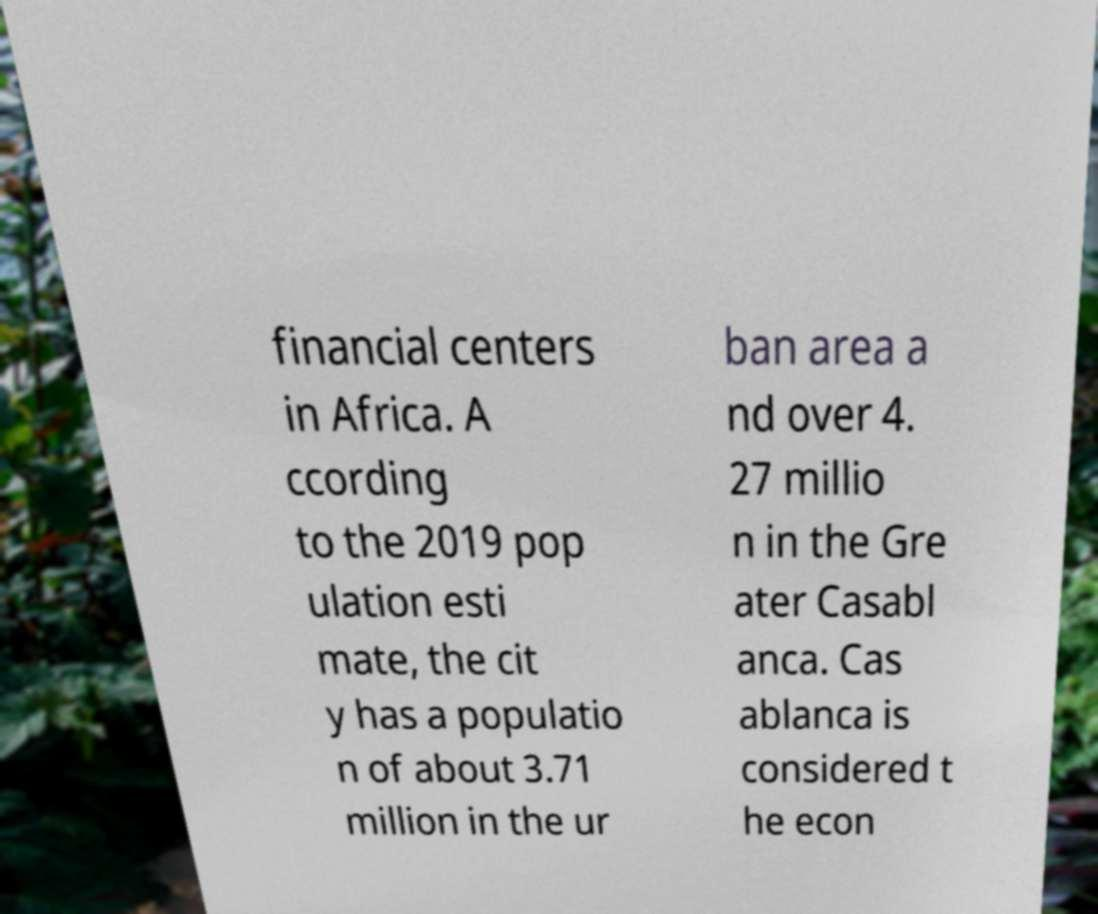Please identify and transcribe the text found in this image. financial centers in Africa. A ccording to the 2019 pop ulation esti mate, the cit y has a populatio n of about 3.71 million in the ur ban area a nd over 4. 27 millio n in the Gre ater Casabl anca. Cas ablanca is considered t he econ 